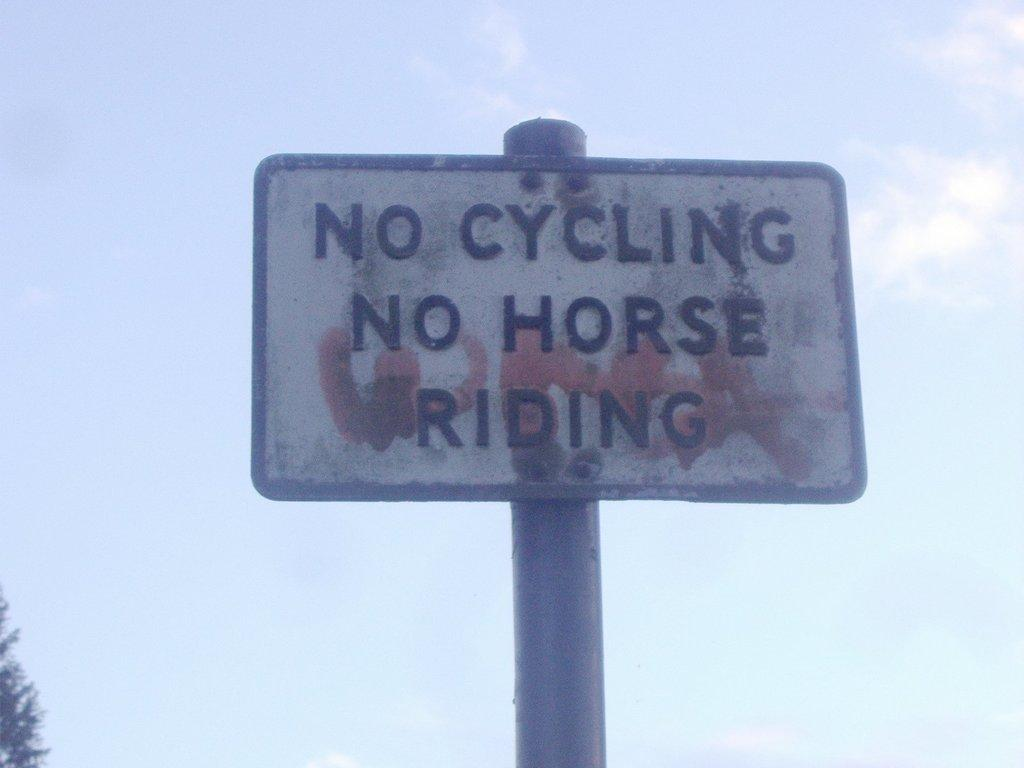<image>
Present a compact description of the photo's key features. A old white sign that says no cycling and no horse riding. 